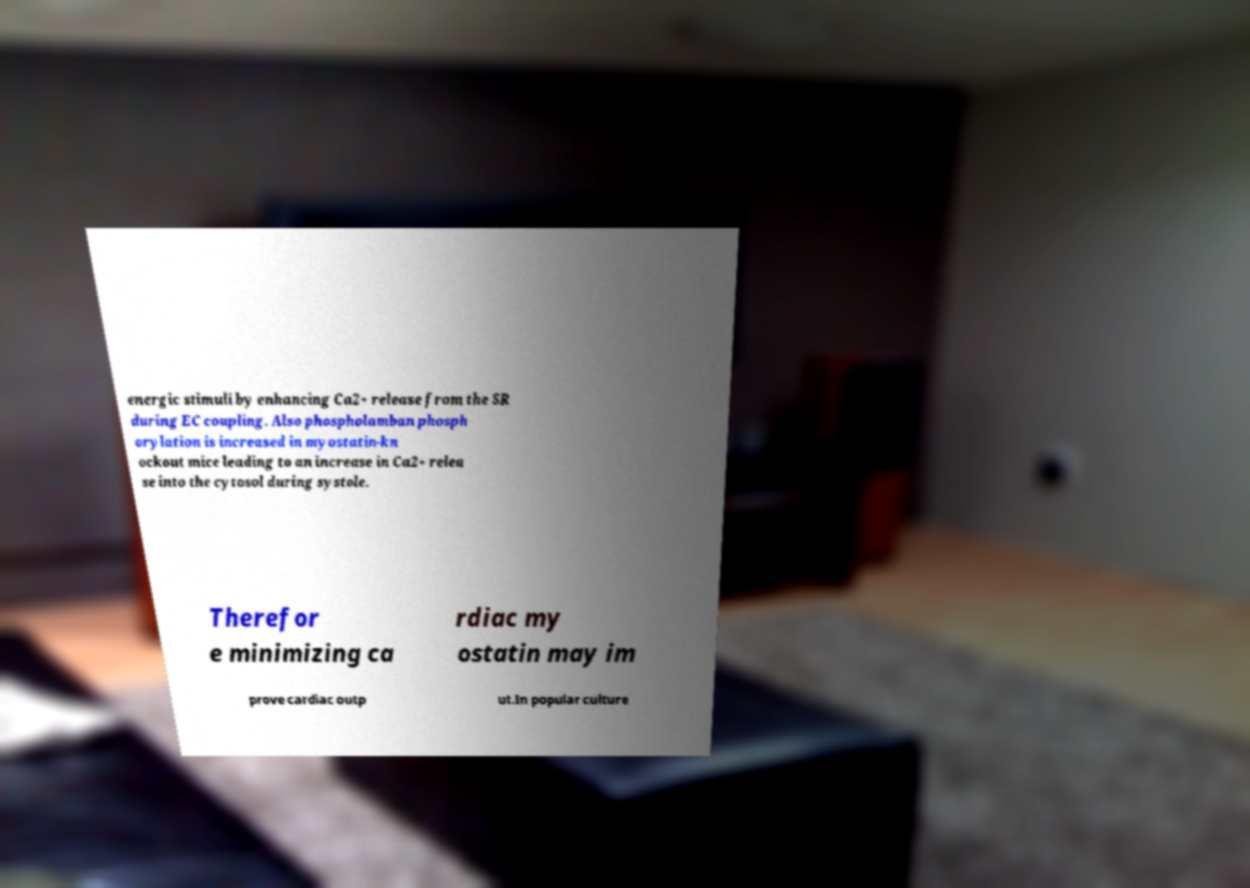Could you extract and type out the text from this image? energic stimuli by enhancing Ca2+ release from the SR during EC coupling. Also phospholamban phosph orylation is increased in myostatin-kn ockout mice leading to an increase in Ca2+ relea se into the cytosol during systole. Therefor e minimizing ca rdiac my ostatin may im prove cardiac outp ut.In popular culture 